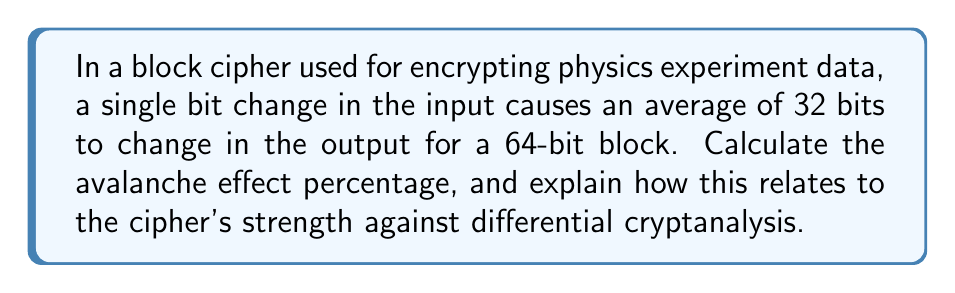Show me your answer to this math problem. To solve this problem, we'll follow these steps:

1) The avalanche effect is measured as the percentage of output bits that change when a single input bit is flipped.

2) In this case:
   - Total bits in the block: 64
   - Average number of bits that change: 32

3) To calculate the percentage, we use the formula:
   
   $$ \text{Avalanche Effect} = \frac{\text{Number of bits changed}}{\text{Total number of bits}} \times 100\% $$

4) Substituting our values:

   $$ \text{Avalanche Effect} = \frac{32}{64} \times 100\% = 0.5 \times 100\% = 50\% $$

5) Interpretation:
   A 50% avalanche effect is considered ideal for a strong cipher. This means that, on average, half of the output bits change when a single input bit is flipped.

6) Relation to differential cryptanalysis:
   A high avalanche effect (close to 50%) makes it difficult for an attacker to predict how small changes in the input will affect the output. This property significantly complicates differential cryptanalysis, which relies on analyzing how differences in the input affect the output.

   In physics terms, this is analogous to chaos theory, where small changes in initial conditions can lead to vastly different outcomes, making predictions extremely difficult.
Answer: 50% 